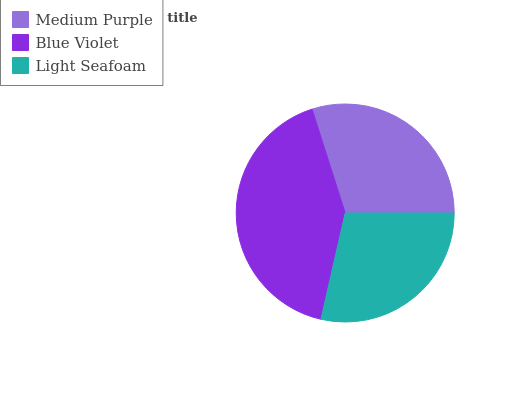Is Light Seafoam the minimum?
Answer yes or no. Yes. Is Blue Violet the maximum?
Answer yes or no. Yes. Is Blue Violet the minimum?
Answer yes or no. No. Is Light Seafoam the maximum?
Answer yes or no. No. Is Blue Violet greater than Light Seafoam?
Answer yes or no. Yes. Is Light Seafoam less than Blue Violet?
Answer yes or no. Yes. Is Light Seafoam greater than Blue Violet?
Answer yes or no. No. Is Blue Violet less than Light Seafoam?
Answer yes or no. No. Is Medium Purple the high median?
Answer yes or no. Yes. Is Medium Purple the low median?
Answer yes or no. Yes. Is Light Seafoam the high median?
Answer yes or no. No. Is Blue Violet the low median?
Answer yes or no. No. 